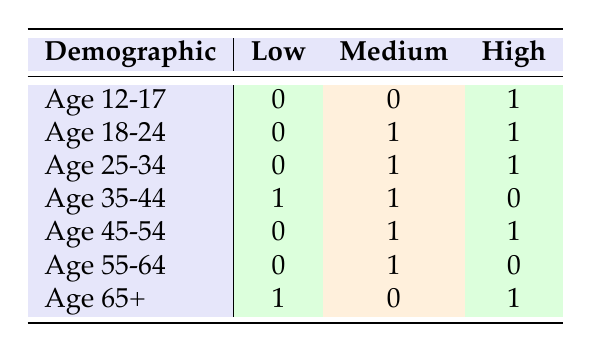What is the engagement level of the "Youth Sports League" for the age group 12-17? The table has a designated row for the demographic "Age 12-17," which shows the "Youth Sports League" engagement level is classified as "High."
Answer: High Which demographic has a "Low" engagement level? The table reveals that the demographic "Age 35-44" and "Age 65+" have a "Low" engagement level, as indicated in their respective rows.
Answer: Age 35-44, Age 65+ What is the total number of demographics with a "Medium" engagement level? By reviewing the table, the rows for "Age 18-24," "Age 25-34," "Age 45-54," and "Age 55-64" indicate "Medium" engagement levels, summing to four demographics in total.
Answer: 4 True or False: The "Environmental Awareness Project" has a "High" engagement level for adults aged 25-34. Referring to the table, "Environmental Awareness Project" does indeed have a "High" engagement level for the demographic "Age 25-34," making this statement true.
Answer: True What is the difference in the number of demographics with "High" versus "Low" engagement levels? The table shows two "High" engagement levels (Age 12-17 and Age 65+) and two "Low" engagement levels (Age 35-44 and Age 65+), resulting in a difference of 2 - 2 = 0.
Answer: 0 What are the engagement levels for the "Crisis Support Helpline"? In the table, the demographic row does not list "Crisis Support Helpline," but observing the row for "Age 45-54," this charity has a classified engagement level of "High."
Answer: High Is it true that all age groups have at least one charity with a "High" engagement level? The table indicates that all age groups listed do indeed have at least one charity with a "High" engagement level, which makes this statement true.
Answer: True How many demographics show "High" engagement levels compared to "Medium"? The number of demographics with "High" engagement levels counts to four (Age 12-17, Age 18-24, Age 25-34, and Age 65+), while those with "Medium" count to five. Hence, comparing 4 "High" to 5 "Medium" means "Medium" levels are more prevalent.
Answer: Medium has 1 more than High 